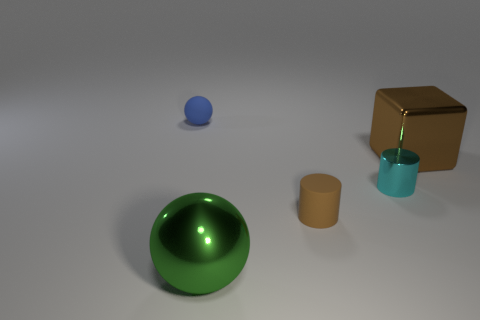Are there any tiny cylinders made of the same material as the small ball?
Provide a succinct answer. Yes. The green metallic thing is what shape?
Keep it short and to the point. Sphere. How many rubber balls are there?
Ensure brevity in your answer.  1. What color is the sphere that is behind the sphere in front of the tiny blue matte sphere?
Offer a very short reply. Blue. There is a shiny cube that is the same size as the green sphere; what color is it?
Offer a terse response. Brown. Is there a matte ball of the same color as the cube?
Give a very brief answer. No. Is there a tiny metallic ball?
Ensure brevity in your answer.  No. What shape is the large shiny thing that is in front of the large brown shiny object?
Ensure brevity in your answer.  Sphere. What number of things are on the left side of the metal cylinder and in front of the big block?
Provide a succinct answer. 2. What number of other things are there of the same size as the cyan metal cylinder?
Your answer should be very brief. 2. 